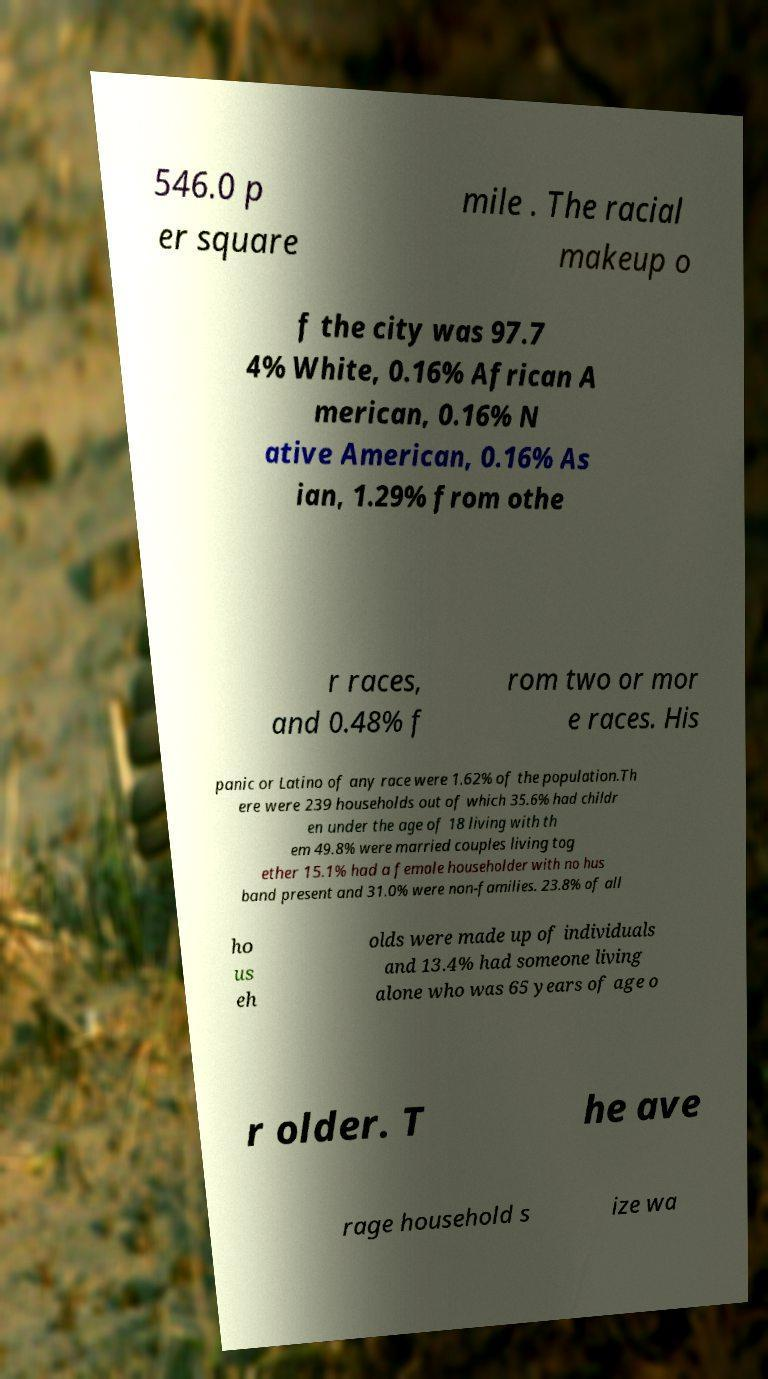What messages or text are displayed in this image? I need them in a readable, typed format. 546.0 p er square mile . The racial makeup o f the city was 97.7 4% White, 0.16% African A merican, 0.16% N ative American, 0.16% As ian, 1.29% from othe r races, and 0.48% f rom two or mor e races. His panic or Latino of any race were 1.62% of the population.Th ere were 239 households out of which 35.6% had childr en under the age of 18 living with th em 49.8% were married couples living tog ether 15.1% had a female householder with no hus band present and 31.0% were non-families. 23.8% of all ho us eh olds were made up of individuals and 13.4% had someone living alone who was 65 years of age o r older. T he ave rage household s ize wa 